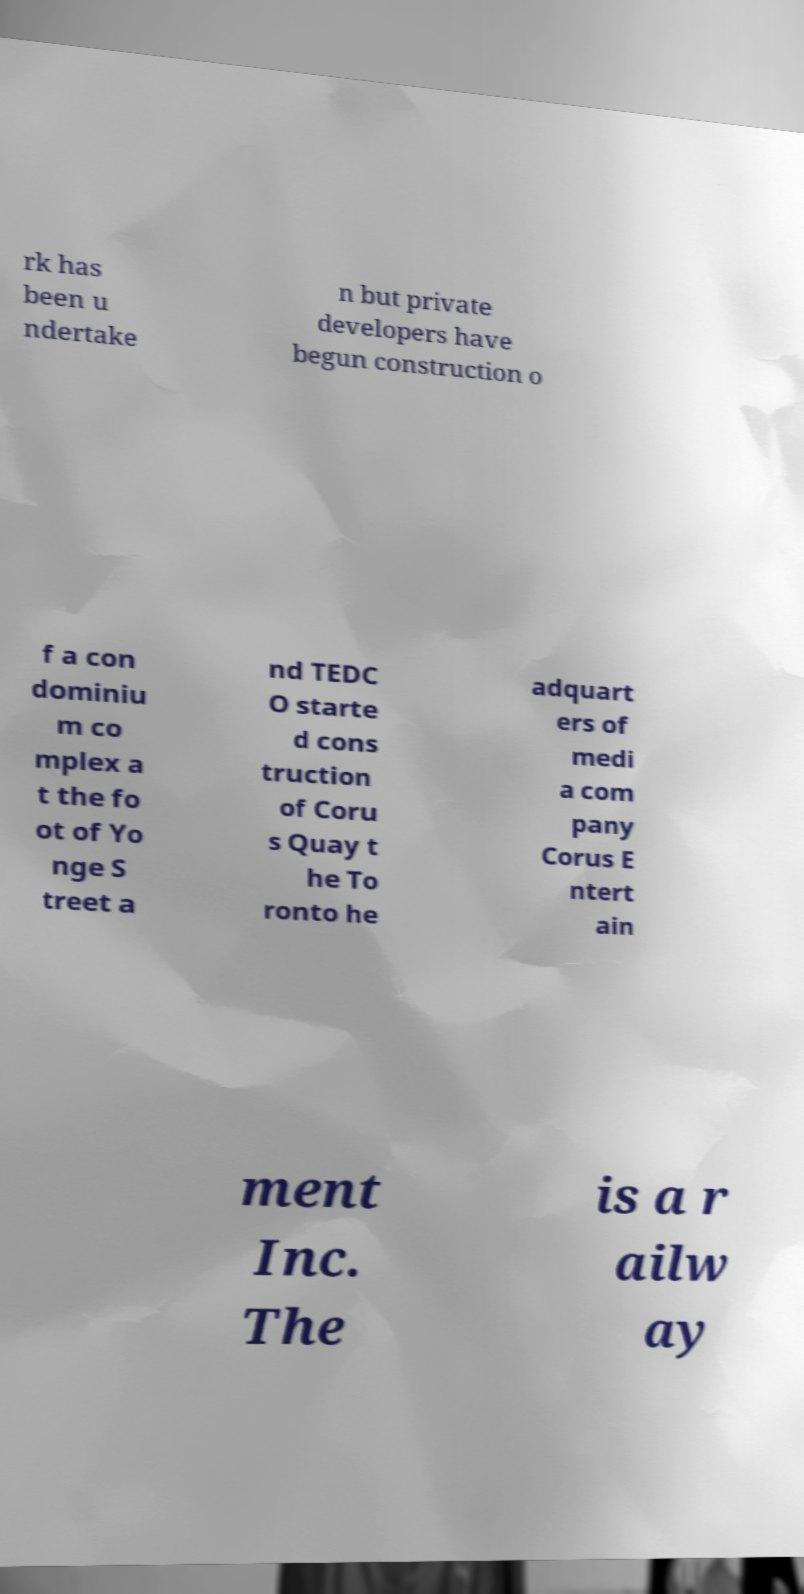Can you accurately transcribe the text from the provided image for me? rk has been u ndertake n but private developers have begun construction o f a con dominiu m co mplex a t the fo ot of Yo nge S treet a nd TEDC O starte d cons truction of Coru s Quay t he To ronto he adquart ers of medi a com pany Corus E ntert ain ment Inc. The is a r ailw ay 